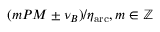<formula> <loc_0><loc_0><loc_500><loc_500>( m P M \pm \nu _ { B } ) / \eta _ { a r c } , m \in \mathbb { Z }</formula> 